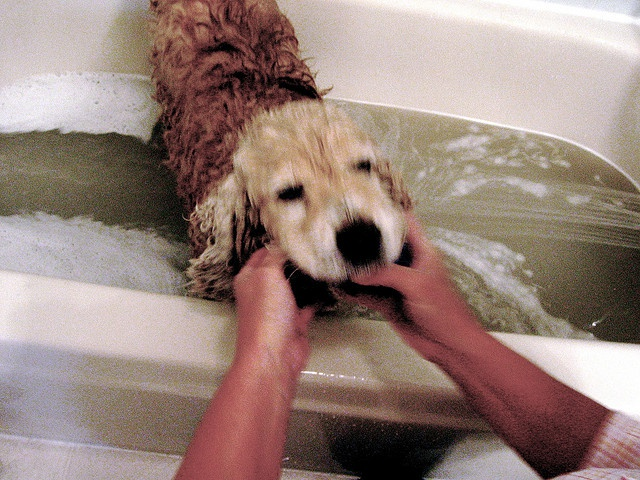Describe the objects in this image and their specific colors. I can see people in lightgray, brown, black, maroon, and darkgray tones and dog in lightgray, brown, maroon, black, and tan tones in this image. 